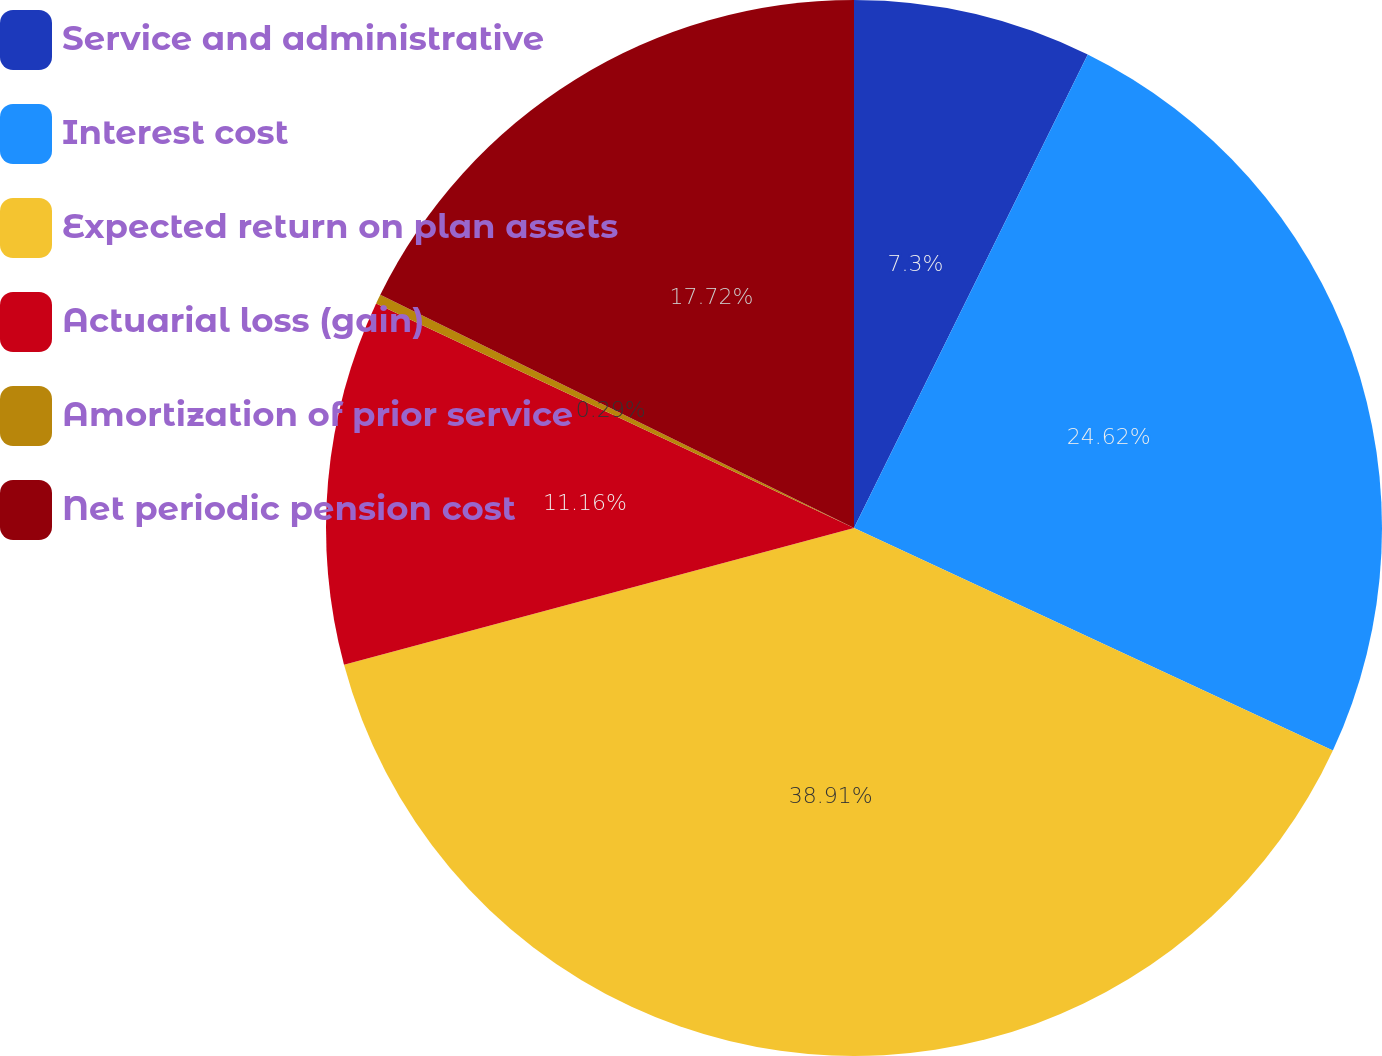Convert chart to OTSL. <chart><loc_0><loc_0><loc_500><loc_500><pie_chart><fcel>Service and administrative<fcel>Interest cost<fcel>Expected return on plan assets<fcel>Actuarial loss (gain)<fcel>Amortization of prior service<fcel>Net periodic pension cost<nl><fcel>7.3%<fcel>24.62%<fcel>38.91%<fcel>11.16%<fcel>0.29%<fcel>17.72%<nl></chart> 